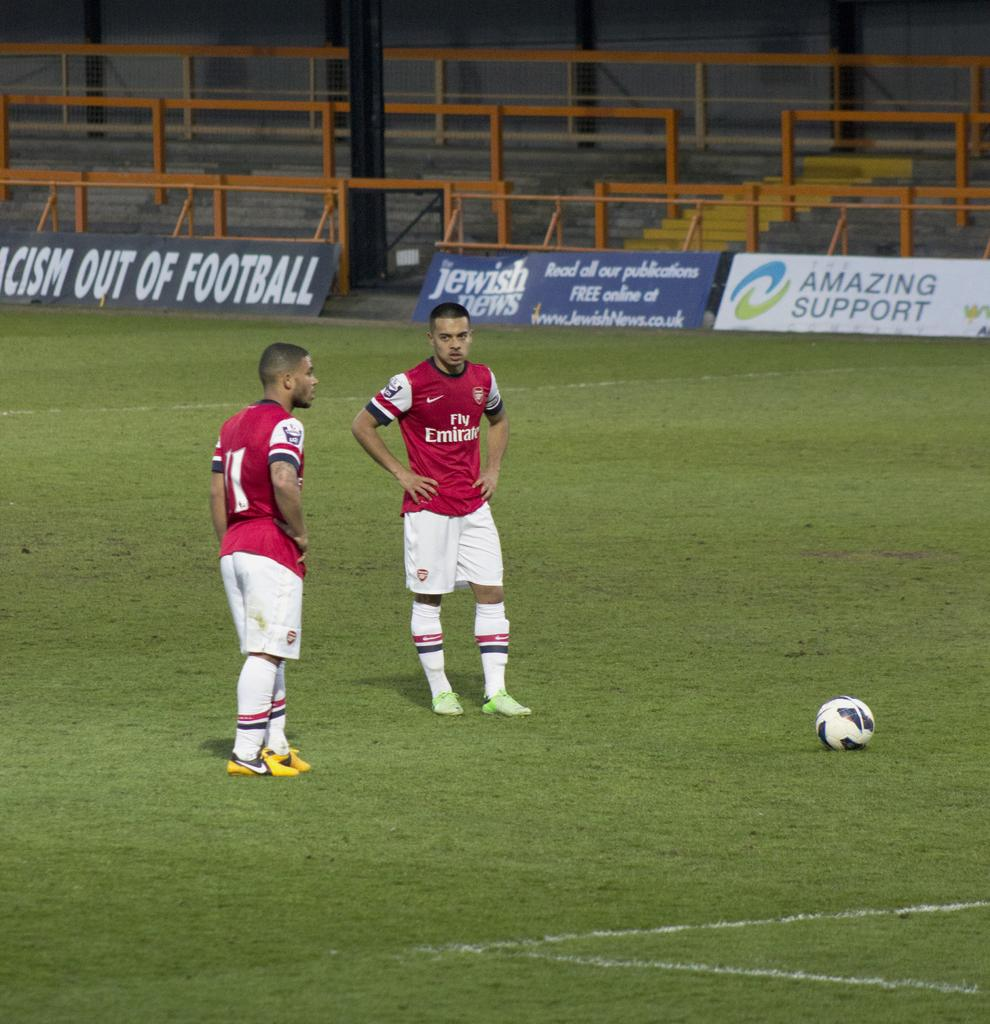<image>
Give a short and clear explanation of the subsequent image. A placard on the edge of the soccer field i by the Jewish news. 